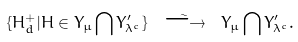<formula> <loc_0><loc_0><loc_500><loc_500>\{ H ^ { + } _ { d } | H \in Y _ { \mu } \bigcap Y ^ { \prime } _ { \lambda ^ { c } } \} \ \stackrel { \sim } { \longrightarrow } \ Y _ { \mu } \bigcap Y ^ { \prime } _ { \lambda ^ { c } } .</formula> 